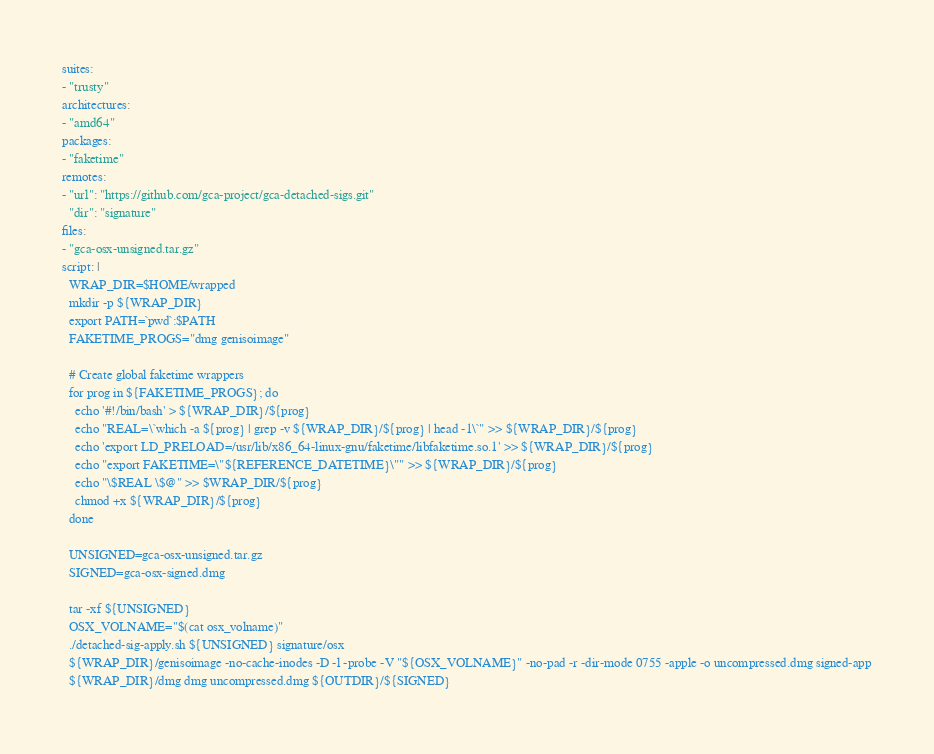<code> <loc_0><loc_0><loc_500><loc_500><_YAML_>suites:
- "trusty"
architectures:
- "amd64"
packages:
- "faketime"
remotes:
- "url": "https://github.com/gca-project/gca-detached-sigs.git"
  "dir": "signature"
files:
- "gca-osx-unsigned.tar.gz"
script: |
  WRAP_DIR=$HOME/wrapped
  mkdir -p ${WRAP_DIR}
  export PATH=`pwd`:$PATH
  FAKETIME_PROGS="dmg genisoimage"

  # Create global faketime wrappers
  for prog in ${FAKETIME_PROGS}; do
    echo '#!/bin/bash' > ${WRAP_DIR}/${prog}
    echo "REAL=\`which -a ${prog} | grep -v ${WRAP_DIR}/${prog} | head -1\`" >> ${WRAP_DIR}/${prog}
    echo 'export LD_PRELOAD=/usr/lib/x86_64-linux-gnu/faketime/libfaketime.so.1' >> ${WRAP_DIR}/${prog}
    echo "export FAKETIME=\"${REFERENCE_DATETIME}\"" >> ${WRAP_DIR}/${prog}
    echo "\$REAL \$@" >> $WRAP_DIR/${prog}
    chmod +x ${WRAP_DIR}/${prog}
  done

  UNSIGNED=gca-osx-unsigned.tar.gz
  SIGNED=gca-osx-signed.dmg

  tar -xf ${UNSIGNED}
  OSX_VOLNAME="$(cat osx_volname)"
  ./detached-sig-apply.sh ${UNSIGNED} signature/osx
  ${WRAP_DIR}/genisoimage -no-cache-inodes -D -l -probe -V "${OSX_VOLNAME}" -no-pad -r -dir-mode 0755 -apple -o uncompressed.dmg signed-app
  ${WRAP_DIR}/dmg dmg uncompressed.dmg ${OUTDIR}/${SIGNED}
</code> 